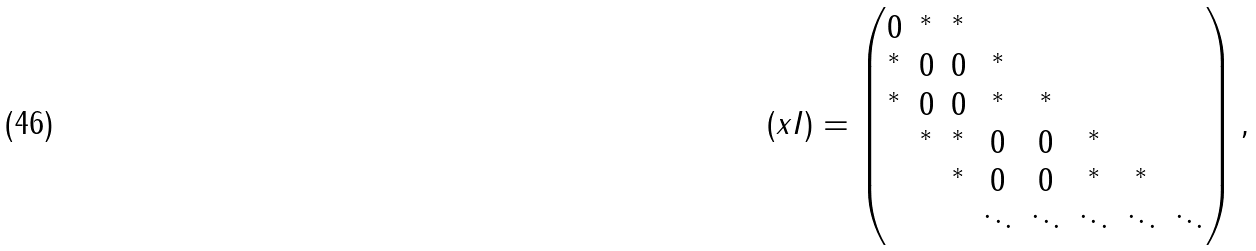<formula> <loc_0><loc_0><loc_500><loc_500>( x I ) = \begin{pmatrix} 0 & ^ { * } & ^ { * } & & & & \\ ^ { * } & 0 & 0 & ^ { * } & & & \\ ^ { * } & 0 & 0 & ^ { * } & ^ { * } & & \\ & ^ { * } & ^ { * } & 0 & 0 & ^ { * } & \\ & & ^ { * } & 0 & 0 & ^ { * } & ^ { * } & \\ & & & \ddots & \ddots & \ddots & \ddots & \ddots \\ \end{pmatrix} ,</formula> 